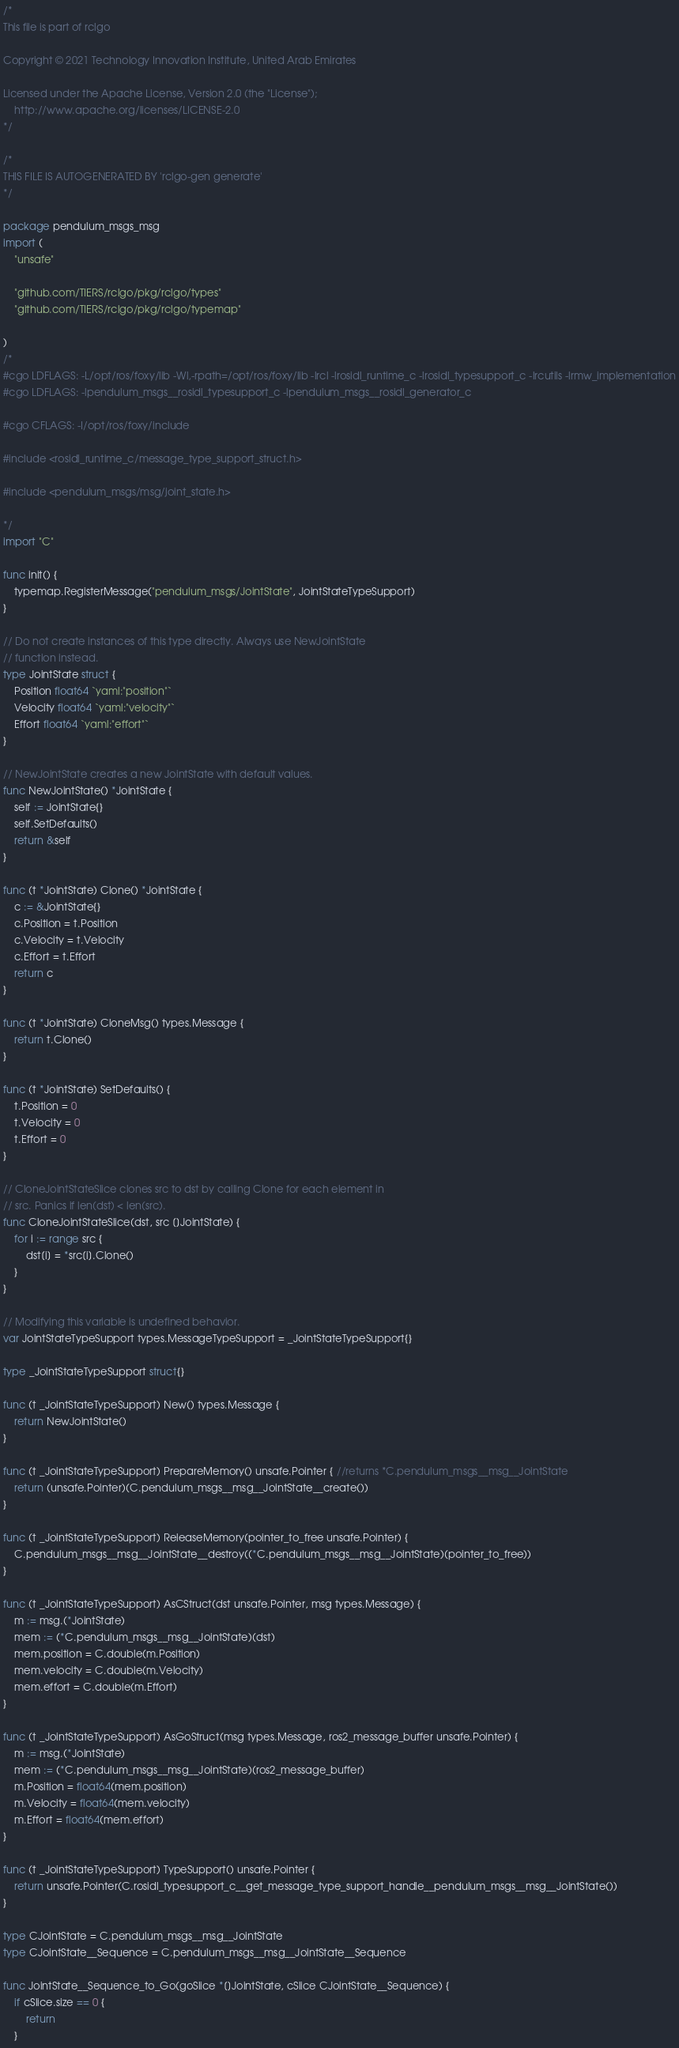Convert code to text. <code><loc_0><loc_0><loc_500><loc_500><_Go_>/*
This file is part of rclgo

Copyright © 2021 Technology Innovation Institute, United Arab Emirates

Licensed under the Apache License, Version 2.0 (the "License");
	http://www.apache.org/licenses/LICENSE-2.0
*/

/*
THIS FILE IS AUTOGENERATED BY 'rclgo-gen generate'
*/

package pendulum_msgs_msg
import (
	"unsafe"

	"github.com/TIERS/rclgo/pkg/rclgo/types"
	"github.com/TIERS/rclgo/pkg/rclgo/typemap"
	
)
/*
#cgo LDFLAGS: -L/opt/ros/foxy/lib -Wl,-rpath=/opt/ros/foxy/lib -lrcl -lrosidl_runtime_c -lrosidl_typesupport_c -lrcutils -lrmw_implementation
#cgo LDFLAGS: -lpendulum_msgs__rosidl_typesupport_c -lpendulum_msgs__rosidl_generator_c

#cgo CFLAGS: -I/opt/ros/foxy/include

#include <rosidl_runtime_c/message_type_support_struct.h>

#include <pendulum_msgs/msg/joint_state.h>

*/
import "C"

func init() {
	typemap.RegisterMessage("pendulum_msgs/JointState", JointStateTypeSupport)
}

// Do not create instances of this type directly. Always use NewJointState
// function instead.
type JointState struct {
	Position float64 `yaml:"position"`
	Velocity float64 `yaml:"velocity"`
	Effort float64 `yaml:"effort"`
}

// NewJointState creates a new JointState with default values.
func NewJointState() *JointState {
	self := JointState{}
	self.SetDefaults()
	return &self
}

func (t *JointState) Clone() *JointState {
	c := &JointState{}
	c.Position = t.Position
	c.Velocity = t.Velocity
	c.Effort = t.Effort
	return c
}

func (t *JointState) CloneMsg() types.Message {
	return t.Clone()
}

func (t *JointState) SetDefaults() {
	t.Position = 0
	t.Velocity = 0
	t.Effort = 0
}

// CloneJointStateSlice clones src to dst by calling Clone for each element in
// src. Panics if len(dst) < len(src).
func CloneJointStateSlice(dst, src []JointState) {
	for i := range src {
		dst[i] = *src[i].Clone()
	}
}

// Modifying this variable is undefined behavior.
var JointStateTypeSupport types.MessageTypeSupport = _JointStateTypeSupport{}

type _JointStateTypeSupport struct{}

func (t _JointStateTypeSupport) New() types.Message {
	return NewJointState()
}

func (t _JointStateTypeSupport) PrepareMemory() unsafe.Pointer { //returns *C.pendulum_msgs__msg__JointState
	return (unsafe.Pointer)(C.pendulum_msgs__msg__JointState__create())
}

func (t _JointStateTypeSupport) ReleaseMemory(pointer_to_free unsafe.Pointer) {
	C.pendulum_msgs__msg__JointState__destroy((*C.pendulum_msgs__msg__JointState)(pointer_to_free))
}

func (t _JointStateTypeSupport) AsCStruct(dst unsafe.Pointer, msg types.Message) {
	m := msg.(*JointState)
	mem := (*C.pendulum_msgs__msg__JointState)(dst)
	mem.position = C.double(m.Position)
	mem.velocity = C.double(m.Velocity)
	mem.effort = C.double(m.Effort)
}

func (t _JointStateTypeSupport) AsGoStruct(msg types.Message, ros2_message_buffer unsafe.Pointer) {
	m := msg.(*JointState)
	mem := (*C.pendulum_msgs__msg__JointState)(ros2_message_buffer)
	m.Position = float64(mem.position)
	m.Velocity = float64(mem.velocity)
	m.Effort = float64(mem.effort)
}

func (t _JointStateTypeSupport) TypeSupport() unsafe.Pointer {
	return unsafe.Pointer(C.rosidl_typesupport_c__get_message_type_support_handle__pendulum_msgs__msg__JointState())
}

type CJointState = C.pendulum_msgs__msg__JointState
type CJointState__Sequence = C.pendulum_msgs__msg__JointState__Sequence

func JointState__Sequence_to_Go(goSlice *[]JointState, cSlice CJointState__Sequence) {
	if cSlice.size == 0 {
		return
	}</code> 